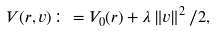<formula> <loc_0><loc_0><loc_500><loc_500>V ( r , v ) \colon = V _ { 0 } ( r ) + \lambda \left \| v \right \| ^ { 2 } / 2 ,</formula> 